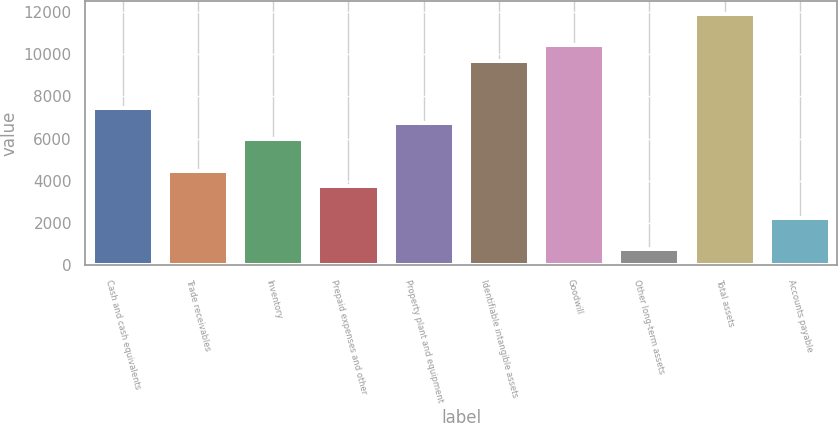Convert chart. <chart><loc_0><loc_0><loc_500><loc_500><bar_chart><fcel>Cash and cash equivalents<fcel>Trade receivables<fcel>Inventory<fcel>Prepaid expenses and other<fcel>Property plant and equipment<fcel>Identifiable intangible assets<fcel>Goodwill<fcel>Other long-term assets<fcel>Total assets<fcel>Accounts payable<nl><fcel>7456.7<fcel>4478.1<fcel>5967.4<fcel>3733.45<fcel>6712.05<fcel>9690.65<fcel>10435.3<fcel>754.85<fcel>11924.6<fcel>2244.15<nl></chart> 